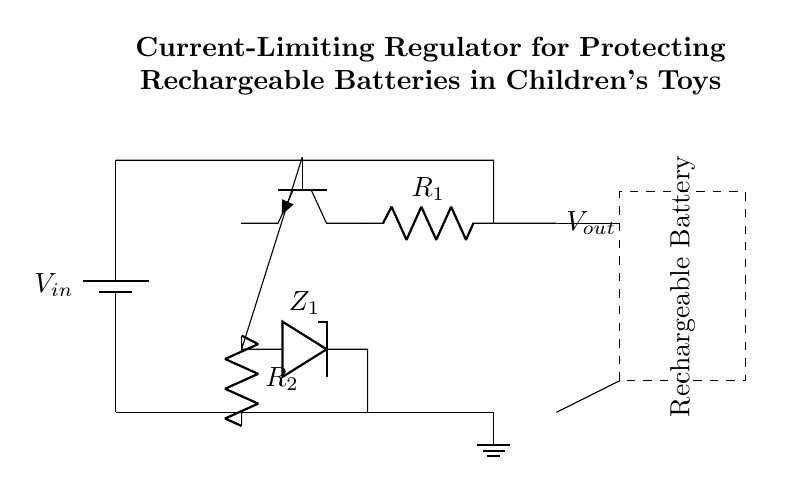What is the input voltage source in this circuit? The input voltage source is represented by the battery symbol labeled V_in, which supplies power to the circuit.
Answer: V_in What components are used to limit the current in this regulator? The current limit in this regulator is primarily controlled by the resistor R_1 and the transistor in the circuit. R_1 sets the base current for the transistor, which regulates the output current.
Answer: R_1 and transistor What is the purpose of the Zener diode in this circuit? The Zener diode, labeled Z_1, serves to provide a stable reference voltage that helps maintain the output voltage across the load and protect the circuit from overvoltage conditions.
Answer: Stable reference voltage How does the configuration of the transistor influence the output current? The transistor acts as a switch and uses the base current flowing through R_2 to control the larger collector-emitter current. This relationship allows it to regulate the output current to the connected rechargeable battery.
Answer: Controls large current What happens if the output current exceeds the limit set by R_1? If the output current exceeds the limit, the transistor will enter saturation, causing it to cut off the current flow to avoid damaging the rechargeable battery and prevent overheating.
Answer: Cuts off current flow What is the significance of the ground connection in this circuit? The ground connection provides a reference point for all voltages in the circuit and ensures a complete path for current to flow, which is essential for the circuit's operation.
Answer: Reference point 